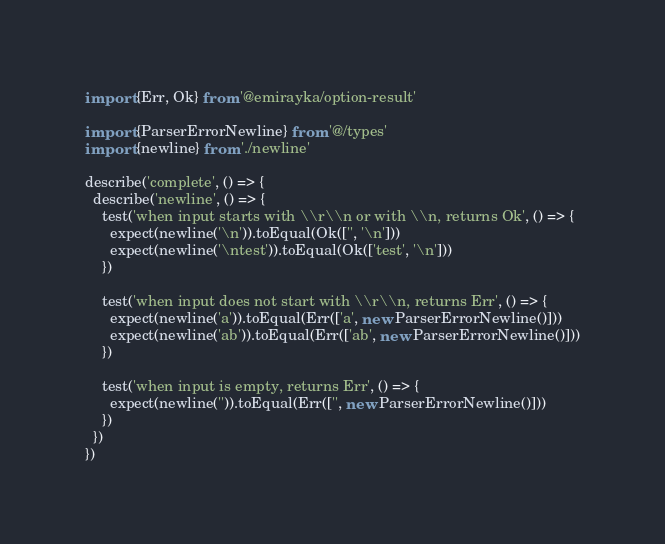<code> <loc_0><loc_0><loc_500><loc_500><_TypeScript_>import {Err, Ok} from '@emirayka/option-result'

import {ParserErrorNewline} from '@/types'
import {newline} from './newline'

describe('complete', () => {
  describe('newline', () => {
    test('when input starts with \\r\\n or with \\n, returns Ok', () => {
      expect(newline('\n')).toEqual(Ok(['', '\n']))
      expect(newline('\ntest')).toEqual(Ok(['test', '\n']))
    })

    test('when input does not start with \\r\\n, returns Err', () => {
      expect(newline('a')).toEqual(Err(['a', new ParserErrorNewline()]))
      expect(newline('ab')).toEqual(Err(['ab', new ParserErrorNewline()]))
    })

    test('when input is empty, returns Err', () => {
      expect(newline('')).toEqual(Err(['', new ParserErrorNewline()]))
    })
  })
})
</code> 